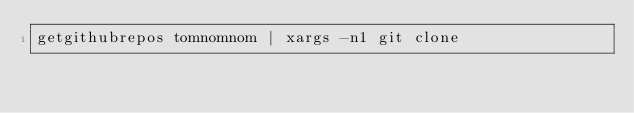Convert code to text. <code><loc_0><loc_0><loc_500><loc_500><_Bash_>getgithubrepos tomnomnom | xargs -n1 git clone 
</code> 